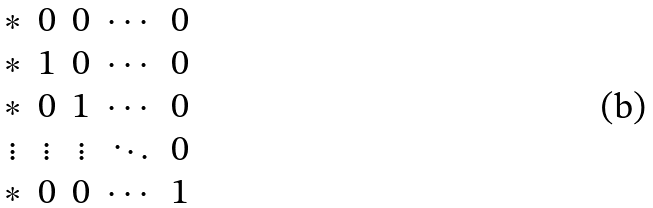<formula> <loc_0><loc_0><loc_500><loc_500>\begin{matrix} * & 0 & 0 & \cdots & 0 \\ * & 1 & 0 & \cdots & 0 \\ * & 0 & 1 & \cdots & 0 \\ \vdots & \vdots & \vdots & \ddots & 0 \\ * & 0 & 0 & \cdots & 1 \end{matrix}</formula> 